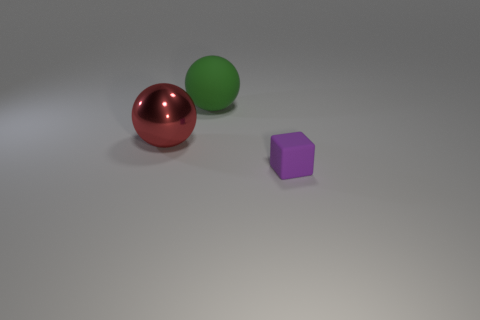Add 3 large green rubber objects. How many objects exist? 6 Subtract all blocks. How many objects are left? 2 Add 1 purple matte blocks. How many purple matte blocks exist? 2 Subtract 0 blue cylinders. How many objects are left? 3 Subtract all big metallic things. Subtract all cyan cubes. How many objects are left? 2 Add 2 matte cubes. How many matte cubes are left? 3 